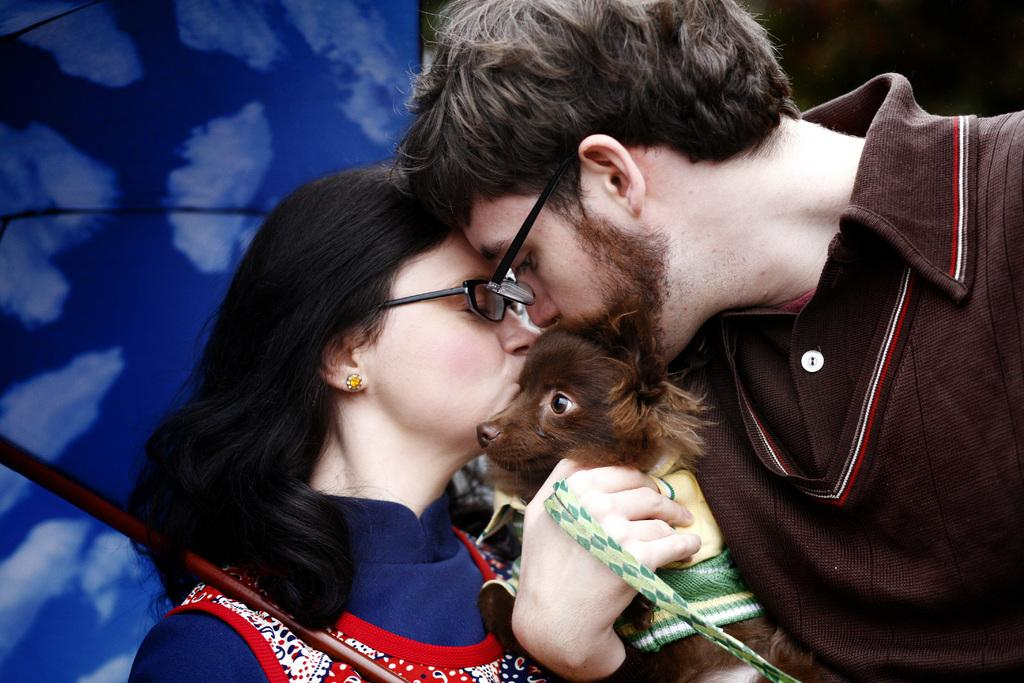How many people are in the image? There are two persons in the image. What are the two persons doing in the image? The two persons are standing and holding a dog. Can you describe the dog in the image? The dog is brown in color and is being held by the two persons. What are the two persons doing with the dog? The two persons are kissing the dog. What can be seen in the background of the image? There is a blue color curtain in the background of the image. What type of songs can be heard playing on the desk in the image? There is no desk present in the image, and therefore no songs can be heard playing. 